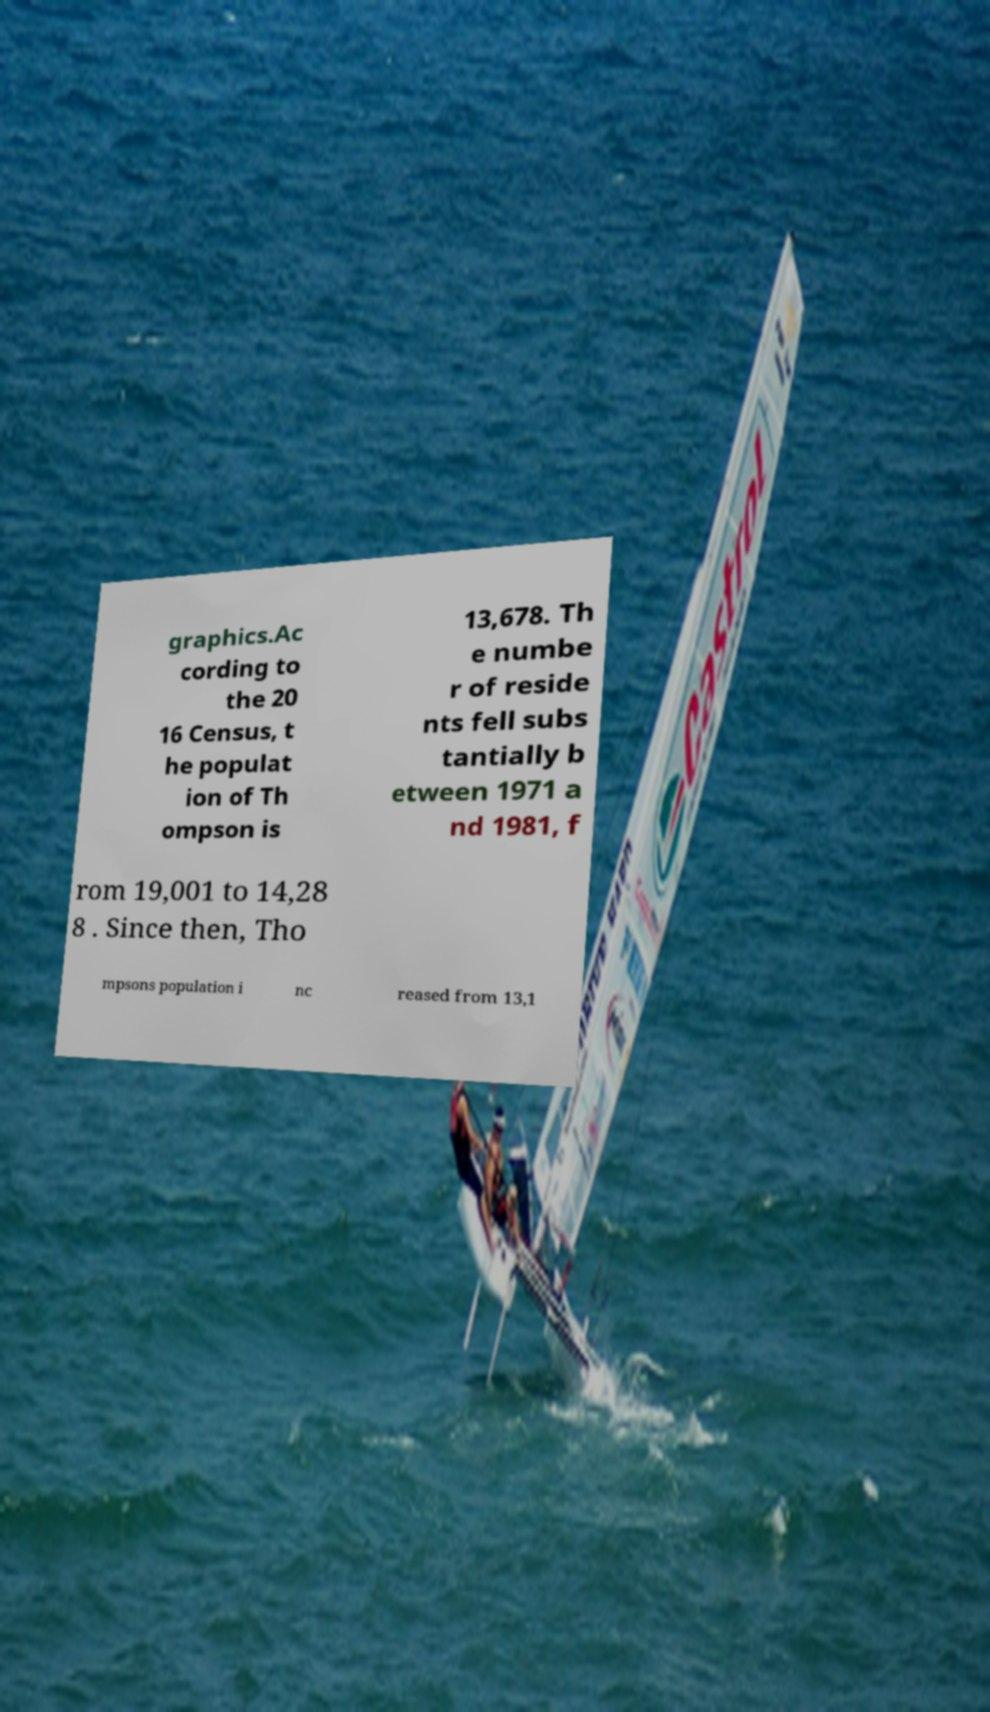For documentation purposes, I need the text within this image transcribed. Could you provide that? graphics.Ac cording to the 20 16 Census, t he populat ion of Th ompson is 13,678. Th e numbe r of reside nts fell subs tantially b etween 1971 a nd 1981, f rom 19,001 to 14,28 8 . Since then, Tho mpsons population i nc reased from 13,1 